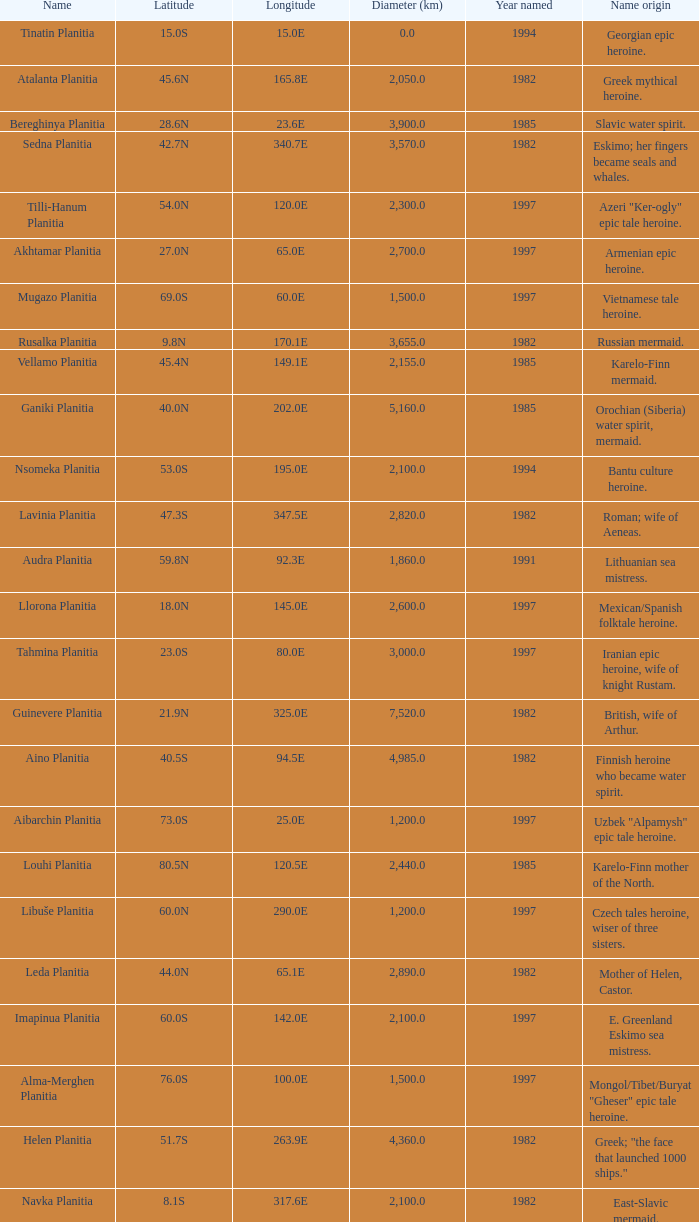1e? 3655.0. 